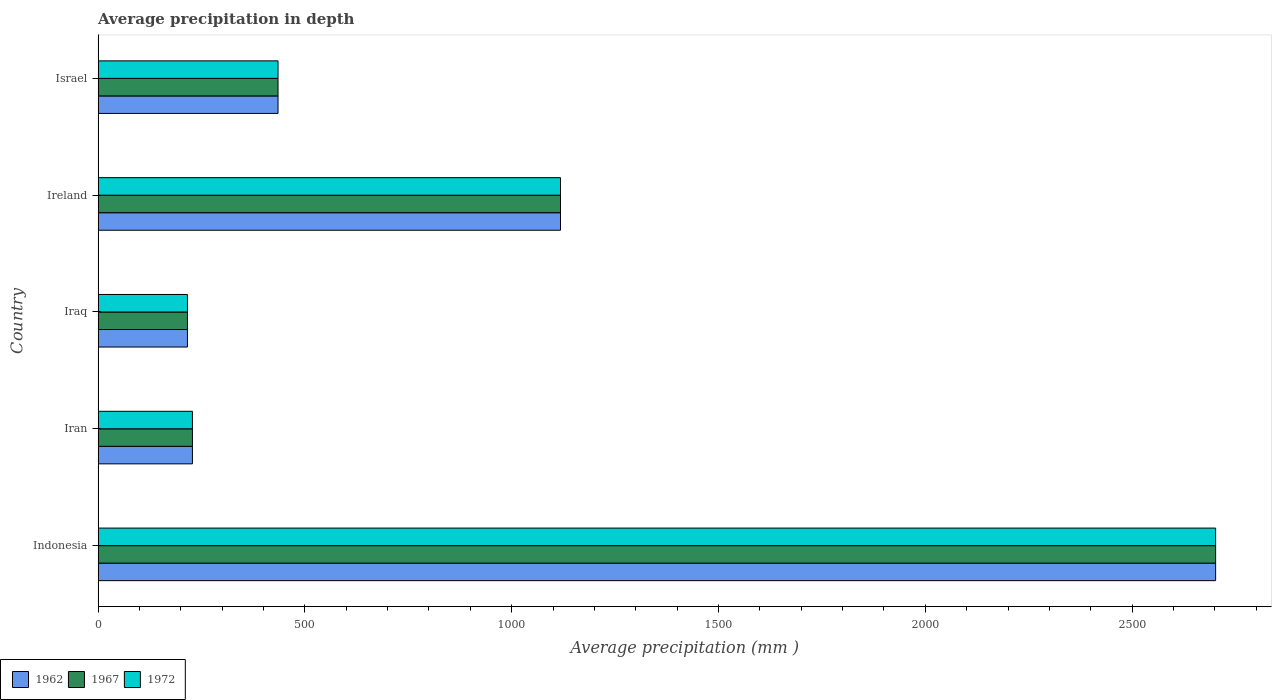How many different coloured bars are there?
Offer a terse response. 3. Are the number of bars on each tick of the Y-axis equal?
Your response must be concise. Yes. What is the average precipitation in 1962 in Israel?
Ensure brevity in your answer.  435. Across all countries, what is the maximum average precipitation in 1962?
Make the answer very short. 2702. Across all countries, what is the minimum average precipitation in 1962?
Keep it short and to the point. 216. In which country was the average precipitation in 1962 minimum?
Your answer should be very brief. Iraq. What is the total average precipitation in 1967 in the graph?
Keep it short and to the point. 4699. What is the difference between the average precipitation in 1967 in Iraq and that in Israel?
Your answer should be compact. -219. What is the difference between the average precipitation in 1962 in Ireland and the average precipitation in 1967 in Iran?
Make the answer very short. 890. What is the average average precipitation in 1962 per country?
Offer a terse response. 939.8. In how many countries, is the average precipitation in 1972 greater than 2200 mm?
Ensure brevity in your answer.  1. What is the ratio of the average precipitation in 1972 in Indonesia to that in Ireland?
Give a very brief answer. 2.42. Is the average precipitation in 1972 in Iran less than that in Israel?
Make the answer very short. Yes. What is the difference between the highest and the second highest average precipitation in 1962?
Offer a terse response. 1584. What is the difference between the highest and the lowest average precipitation in 1962?
Your answer should be very brief. 2486. Is the sum of the average precipitation in 1962 in Iraq and Ireland greater than the maximum average precipitation in 1972 across all countries?
Make the answer very short. No. What does the 2nd bar from the top in Ireland represents?
Make the answer very short. 1967. What does the 2nd bar from the bottom in Iraq represents?
Provide a short and direct response. 1967. Is it the case that in every country, the sum of the average precipitation in 1967 and average precipitation in 1962 is greater than the average precipitation in 1972?
Your answer should be compact. Yes. How many bars are there?
Make the answer very short. 15. Are all the bars in the graph horizontal?
Your answer should be compact. Yes. How many countries are there in the graph?
Provide a short and direct response. 5. What is the difference between two consecutive major ticks on the X-axis?
Ensure brevity in your answer.  500. Are the values on the major ticks of X-axis written in scientific E-notation?
Make the answer very short. No. Does the graph contain any zero values?
Offer a very short reply. No. Does the graph contain grids?
Offer a terse response. No. What is the title of the graph?
Provide a succinct answer. Average precipitation in depth. What is the label or title of the X-axis?
Make the answer very short. Average precipitation (mm ). What is the label or title of the Y-axis?
Give a very brief answer. Country. What is the Average precipitation (mm ) in 1962 in Indonesia?
Make the answer very short. 2702. What is the Average precipitation (mm ) of 1967 in Indonesia?
Provide a short and direct response. 2702. What is the Average precipitation (mm ) of 1972 in Indonesia?
Your answer should be compact. 2702. What is the Average precipitation (mm ) in 1962 in Iran?
Provide a succinct answer. 228. What is the Average precipitation (mm ) in 1967 in Iran?
Offer a very short reply. 228. What is the Average precipitation (mm ) of 1972 in Iran?
Offer a terse response. 228. What is the Average precipitation (mm ) in 1962 in Iraq?
Offer a terse response. 216. What is the Average precipitation (mm ) in 1967 in Iraq?
Your answer should be very brief. 216. What is the Average precipitation (mm ) in 1972 in Iraq?
Your answer should be very brief. 216. What is the Average precipitation (mm ) of 1962 in Ireland?
Offer a terse response. 1118. What is the Average precipitation (mm ) of 1967 in Ireland?
Your answer should be very brief. 1118. What is the Average precipitation (mm ) of 1972 in Ireland?
Provide a short and direct response. 1118. What is the Average precipitation (mm ) in 1962 in Israel?
Give a very brief answer. 435. What is the Average precipitation (mm ) in 1967 in Israel?
Give a very brief answer. 435. What is the Average precipitation (mm ) in 1972 in Israel?
Your answer should be compact. 435. Across all countries, what is the maximum Average precipitation (mm ) in 1962?
Give a very brief answer. 2702. Across all countries, what is the maximum Average precipitation (mm ) of 1967?
Ensure brevity in your answer.  2702. Across all countries, what is the maximum Average precipitation (mm ) of 1972?
Your answer should be compact. 2702. Across all countries, what is the minimum Average precipitation (mm ) in 1962?
Give a very brief answer. 216. Across all countries, what is the minimum Average precipitation (mm ) in 1967?
Make the answer very short. 216. Across all countries, what is the minimum Average precipitation (mm ) of 1972?
Make the answer very short. 216. What is the total Average precipitation (mm ) of 1962 in the graph?
Offer a terse response. 4699. What is the total Average precipitation (mm ) of 1967 in the graph?
Give a very brief answer. 4699. What is the total Average precipitation (mm ) of 1972 in the graph?
Make the answer very short. 4699. What is the difference between the Average precipitation (mm ) of 1962 in Indonesia and that in Iran?
Your answer should be compact. 2474. What is the difference between the Average precipitation (mm ) of 1967 in Indonesia and that in Iran?
Keep it short and to the point. 2474. What is the difference between the Average precipitation (mm ) of 1972 in Indonesia and that in Iran?
Make the answer very short. 2474. What is the difference between the Average precipitation (mm ) of 1962 in Indonesia and that in Iraq?
Offer a terse response. 2486. What is the difference between the Average precipitation (mm ) of 1967 in Indonesia and that in Iraq?
Keep it short and to the point. 2486. What is the difference between the Average precipitation (mm ) in 1972 in Indonesia and that in Iraq?
Give a very brief answer. 2486. What is the difference between the Average precipitation (mm ) in 1962 in Indonesia and that in Ireland?
Your answer should be compact. 1584. What is the difference between the Average precipitation (mm ) of 1967 in Indonesia and that in Ireland?
Provide a succinct answer. 1584. What is the difference between the Average precipitation (mm ) in 1972 in Indonesia and that in Ireland?
Provide a short and direct response. 1584. What is the difference between the Average precipitation (mm ) in 1962 in Indonesia and that in Israel?
Keep it short and to the point. 2267. What is the difference between the Average precipitation (mm ) in 1967 in Indonesia and that in Israel?
Your response must be concise. 2267. What is the difference between the Average precipitation (mm ) of 1972 in Indonesia and that in Israel?
Offer a very short reply. 2267. What is the difference between the Average precipitation (mm ) in 1972 in Iran and that in Iraq?
Your response must be concise. 12. What is the difference between the Average precipitation (mm ) in 1962 in Iran and that in Ireland?
Give a very brief answer. -890. What is the difference between the Average precipitation (mm ) in 1967 in Iran and that in Ireland?
Your answer should be very brief. -890. What is the difference between the Average precipitation (mm ) in 1972 in Iran and that in Ireland?
Offer a very short reply. -890. What is the difference between the Average precipitation (mm ) in 1962 in Iran and that in Israel?
Give a very brief answer. -207. What is the difference between the Average precipitation (mm ) in 1967 in Iran and that in Israel?
Offer a terse response. -207. What is the difference between the Average precipitation (mm ) in 1972 in Iran and that in Israel?
Keep it short and to the point. -207. What is the difference between the Average precipitation (mm ) of 1962 in Iraq and that in Ireland?
Provide a short and direct response. -902. What is the difference between the Average precipitation (mm ) in 1967 in Iraq and that in Ireland?
Provide a short and direct response. -902. What is the difference between the Average precipitation (mm ) of 1972 in Iraq and that in Ireland?
Provide a succinct answer. -902. What is the difference between the Average precipitation (mm ) of 1962 in Iraq and that in Israel?
Ensure brevity in your answer.  -219. What is the difference between the Average precipitation (mm ) in 1967 in Iraq and that in Israel?
Make the answer very short. -219. What is the difference between the Average precipitation (mm ) in 1972 in Iraq and that in Israel?
Ensure brevity in your answer.  -219. What is the difference between the Average precipitation (mm ) of 1962 in Ireland and that in Israel?
Offer a terse response. 683. What is the difference between the Average precipitation (mm ) of 1967 in Ireland and that in Israel?
Offer a very short reply. 683. What is the difference between the Average precipitation (mm ) of 1972 in Ireland and that in Israel?
Your response must be concise. 683. What is the difference between the Average precipitation (mm ) of 1962 in Indonesia and the Average precipitation (mm ) of 1967 in Iran?
Ensure brevity in your answer.  2474. What is the difference between the Average precipitation (mm ) in 1962 in Indonesia and the Average precipitation (mm ) in 1972 in Iran?
Your answer should be compact. 2474. What is the difference between the Average precipitation (mm ) of 1967 in Indonesia and the Average precipitation (mm ) of 1972 in Iran?
Your answer should be very brief. 2474. What is the difference between the Average precipitation (mm ) in 1962 in Indonesia and the Average precipitation (mm ) in 1967 in Iraq?
Your response must be concise. 2486. What is the difference between the Average precipitation (mm ) of 1962 in Indonesia and the Average precipitation (mm ) of 1972 in Iraq?
Ensure brevity in your answer.  2486. What is the difference between the Average precipitation (mm ) of 1967 in Indonesia and the Average precipitation (mm ) of 1972 in Iraq?
Make the answer very short. 2486. What is the difference between the Average precipitation (mm ) in 1962 in Indonesia and the Average precipitation (mm ) in 1967 in Ireland?
Provide a succinct answer. 1584. What is the difference between the Average precipitation (mm ) of 1962 in Indonesia and the Average precipitation (mm ) of 1972 in Ireland?
Your answer should be compact. 1584. What is the difference between the Average precipitation (mm ) of 1967 in Indonesia and the Average precipitation (mm ) of 1972 in Ireland?
Ensure brevity in your answer.  1584. What is the difference between the Average precipitation (mm ) in 1962 in Indonesia and the Average precipitation (mm ) in 1967 in Israel?
Keep it short and to the point. 2267. What is the difference between the Average precipitation (mm ) of 1962 in Indonesia and the Average precipitation (mm ) of 1972 in Israel?
Your response must be concise. 2267. What is the difference between the Average precipitation (mm ) of 1967 in Indonesia and the Average precipitation (mm ) of 1972 in Israel?
Ensure brevity in your answer.  2267. What is the difference between the Average precipitation (mm ) in 1962 in Iran and the Average precipitation (mm ) in 1972 in Iraq?
Provide a succinct answer. 12. What is the difference between the Average precipitation (mm ) of 1962 in Iran and the Average precipitation (mm ) of 1967 in Ireland?
Offer a terse response. -890. What is the difference between the Average precipitation (mm ) of 1962 in Iran and the Average precipitation (mm ) of 1972 in Ireland?
Your answer should be compact. -890. What is the difference between the Average precipitation (mm ) of 1967 in Iran and the Average precipitation (mm ) of 1972 in Ireland?
Your answer should be compact. -890. What is the difference between the Average precipitation (mm ) of 1962 in Iran and the Average precipitation (mm ) of 1967 in Israel?
Your response must be concise. -207. What is the difference between the Average precipitation (mm ) of 1962 in Iran and the Average precipitation (mm ) of 1972 in Israel?
Keep it short and to the point. -207. What is the difference between the Average precipitation (mm ) of 1967 in Iran and the Average precipitation (mm ) of 1972 in Israel?
Ensure brevity in your answer.  -207. What is the difference between the Average precipitation (mm ) of 1962 in Iraq and the Average precipitation (mm ) of 1967 in Ireland?
Give a very brief answer. -902. What is the difference between the Average precipitation (mm ) of 1962 in Iraq and the Average precipitation (mm ) of 1972 in Ireland?
Your answer should be very brief. -902. What is the difference between the Average precipitation (mm ) of 1967 in Iraq and the Average precipitation (mm ) of 1972 in Ireland?
Your answer should be compact. -902. What is the difference between the Average precipitation (mm ) of 1962 in Iraq and the Average precipitation (mm ) of 1967 in Israel?
Ensure brevity in your answer.  -219. What is the difference between the Average precipitation (mm ) of 1962 in Iraq and the Average precipitation (mm ) of 1972 in Israel?
Your answer should be very brief. -219. What is the difference between the Average precipitation (mm ) in 1967 in Iraq and the Average precipitation (mm ) in 1972 in Israel?
Keep it short and to the point. -219. What is the difference between the Average precipitation (mm ) of 1962 in Ireland and the Average precipitation (mm ) of 1967 in Israel?
Keep it short and to the point. 683. What is the difference between the Average precipitation (mm ) of 1962 in Ireland and the Average precipitation (mm ) of 1972 in Israel?
Your response must be concise. 683. What is the difference between the Average precipitation (mm ) in 1967 in Ireland and the Average precipitation (mm ) in 1972 in Israel?
Your answer should be very brief. 683. What is the average Average precipitation (mm ) of 1962 per country?
Provide a succinct answer. 939.8. What is the average Average precipitation (mm ) in 1967 per country?
Provide a short and direct response. 939.8. What is the average Average precipitation (mm ) of 1972 per country?
Your answer should be very brief. 939.8. What is the difference between the Average precipitation (mm ) in 1962 and Average precipitation (mm ) in 1967 in Indonesia?
Your response must be concise. 0. What is the difference between the Average precipitation (mm ) in 1962 and Average precipitation (mm ) in 1972 in Indonesia?
Ensure brevity in your answer.  0. What is the difference between the Average precipitation (mm ) in 1962 and Average precipitation (mm ) in 1967 in Iran?
Give a very brief answer. 0. What is the difference between the Average precipitation (mm ) of 1962 and Average precipitation (mm ) of 1972 in Iran?
Make the answer very short. 0. What is the difference between the Average precipitation (mm ) in 1967 and Average precipitation (mm ) in 1972 in Iran?
Offer a very short reply. 0. What is the difference between the Average precipitation (mm ) in 1962 and Average precipitation (mm ) in 1972 in Ireland?
Make the answer very short. 0. What is the difference between the Average precipitation (mm ) in 1967 and Average precipitation (mm ) in 1972 in Ireland?
Provide a short and direct response. 0. What is the difference between the Average precipitation (mm ) of 1967 and Average precipitation (mm ) of 1972 in Israel?
Ensure brevity in your answer.  0. What is the ratio of the Average precipitation (mm ) in 1962 in Indonesia to that in Iran?
Keep it short and to the point. 11.85. What is the ratio of the Average precipitation (mm ) in 1967 in Indonesia to that in Iran?
Give a very brief answer. 11.85. What is the ratio of the Average precipitation (mm ) in 1972 in Indonesia to that in Iran?
Your answer should be compact. 11.85. What is the ratio of the Average precipitation (mm ) in 1962 in Indonesia to that in Iraq?
Provide a succinct answer. 12.51. What is the ratio of the Average precipitation (mm ) in 1967 in Indonesia to that in Iraq?
Your answer should be very brief. 12.51. What is the ratio of the Average precipitation (mm ) in 1972 in Indonesia to that in Iraq?
Make the answer very short. 12.51. What is the ratio of the Average precipitation (mm ) in 1962 in Indonesia to that in Ireland?
Keep it short and to the point. 2.42. What is the ratio of the Average precipitation (mm ) of 1967 in Indonesia to that in Ireland?
Provide a short and direct response. 2.42. What is the ratio of the Average precipitation (mm ) in 1972 in Indonesia to that in Ireland?
Your answer should be very brief. 2.42. What is the ratio of the Average precipitation (mm ) of 1962 in Indonesia to that in Israel?
Offer a very short reply. 6.21. What is the ratio of the Average precipitation (mm ) in 1967 in Indonesia to that in Israel?
Offer a very short reply. 6.21. What is the ratio of the Average precipitation (mm ) in 1972 in Indonesia to that in Israel?
Ensure brevity in your answer.  6.21. What is the ratio of the Average precipitation (mm ) of 1962 in Iran to that in Iraq?
Your answer should be compact. 1.06. What is the ratio of the Average precipitation (mm ) of 1967 in Iran to that in Iraq?
Offer a terse response. 1.06. What is the ratio of the Average precipitation (mm ) of 1972 in Iran to that in Iraq?
Provide a short and direct response. 1.06. What is the ratio of the Average precipitation (mm ) in 1962 in Iran to that in Ireland?
Offer a terse response. 0.2. What is the ratio of the Average precipitation (mm ) of 1967 in Iran to that in Ireland?
Give a very brief answer. 0.2. What is the ratio of the Average precipitation (mm ) in 1972 in Iran to that in Ireland?
Your answer should be very brief. 0.2. What is the ratio of the Average precipitation (mm ) of 1962 in Iran to that in Israel?
Make the answer very short. 0.52. What is the ratio of the Average precipitation (mm ) in 1967 in Iran to that in Israel?
Provide a succinct answer. 0.52. What is the ratio of the Average precipitation (mm ) of 1972 in Iran to that in Israel?
Give a very brief answer. 0.52. What is the ratio of the Average precipitation (mm ) of 1962 in Iraq to that in Ireland?
Ensure brevity in your answer.  0.19. What is the ratio of the Average precipitation (mm ) in 1967 in Iraq to that in Ireland?
Offer a very short reply. 0.19. What is the ratio of the Average precipitation (mm ) in 1972 in Iraq to that in Ireland?
Make the answer very short. 0.19. What is the ratio of the Average precipitation (mm ) in 1962 in Iraq to that in Israel?
Offer a very short reply. 0.5. What is the ratio of the Average precipitation (mm ) in 1967 in Iraq to that in Israel?
Offer a terse response. 0.5. What is the ratio of the Average precipitation (mm ) of 1972 in Iraq to that in Israel?
Your answer should be very brief. 0.5. What is the ratio of the Average precipitation (mm ) in 1962 in Ireland to that in Israel?
Provide a succinct answer. 2.57. What is the ratio of the Average precipitation (mm ) in 1967 in Ireland to that in Israel?
Provide a succinct answer. 2.57. What is the ratio of the Average precipitation (mm ) of 1972 in Ireland to that in Israel?
Your response must be concise. 2.57. What is the difference between the highest and the second highest Average precipitation (mm ) of 1962?
Provide a short and direct response. 1584. What is the difference between the highest and the second highest Average precipitation (mm ) of 1967?
Keep it short and to the point. 1584. What is the difference between the highest and the second highest Average precipitation (mm ) in 1972?
Provide a succinct answer. 1584. What is the difference between the highest and the lowest Average precipitation (mm ) in 1962?
Keep it short and to the point. 2486. What is the difference between the highest and the lowest Average precipitation (mm ) in 1967?
Provide a short and direct response. 2486. What is the difference between the highest and the lowest Average precipitation (mm ) of 1972?
Your answer should be compact. 2486. 